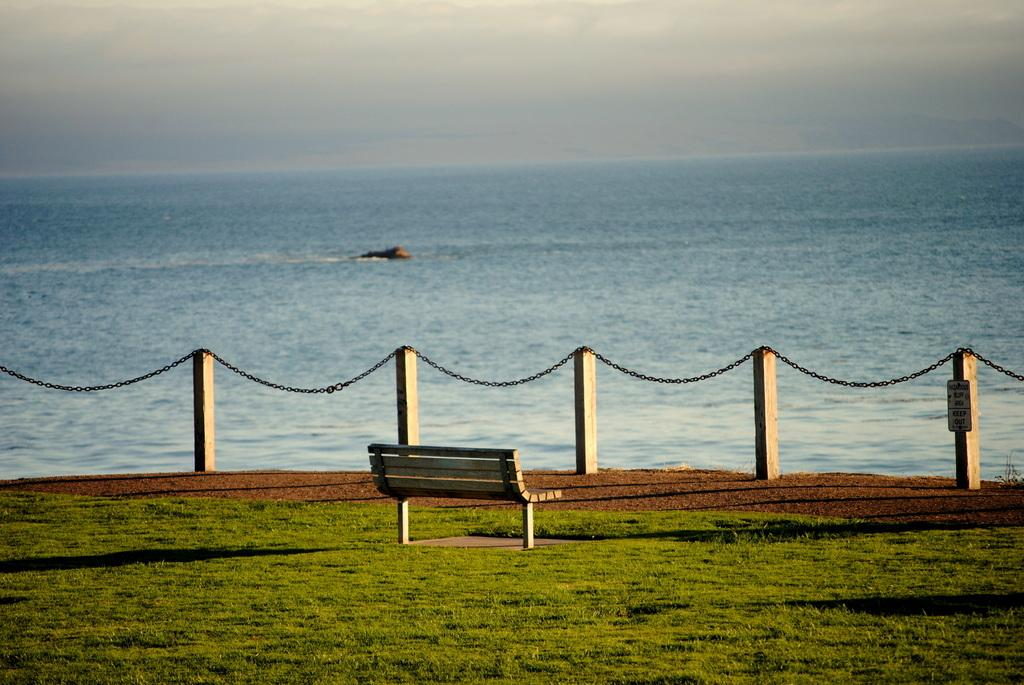What type of barrier is present in the image? There is a wooden fence in the image. What feature is included in the wooden fence? The wooden fence includes a chain. What type of seating is available in the image? There is a sitting bench in the image. What type of vegetation is visible in the image? Grass is visible in the image. What natural element is visible in the image? Water is visible in the image. What part of the natural environment is visible in the image? The sky is visible in the image. What color is the brain that is visible in the image? There is no brain present in the image. Where is the drawer located in the image? There is no drawer present in the image. 